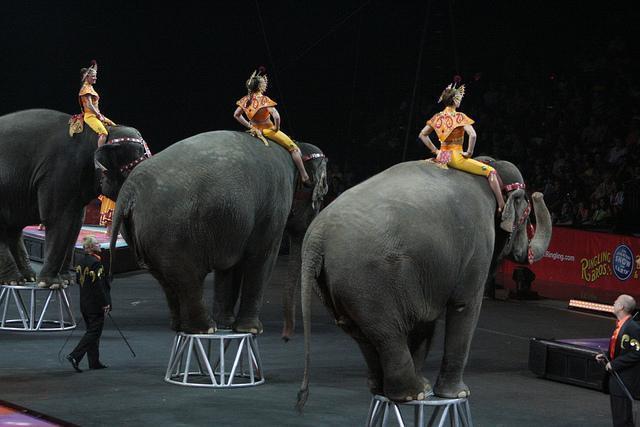What will the man do to the elephants with the sticks he holds?
Pick the right solution, then justify: 'Answer: answer
Rationale: rationale.'
Options: Kill them, poke them, mesmerize them, feed them. Answer: poke them.
Rationale: He will do this to tell them what to do next 